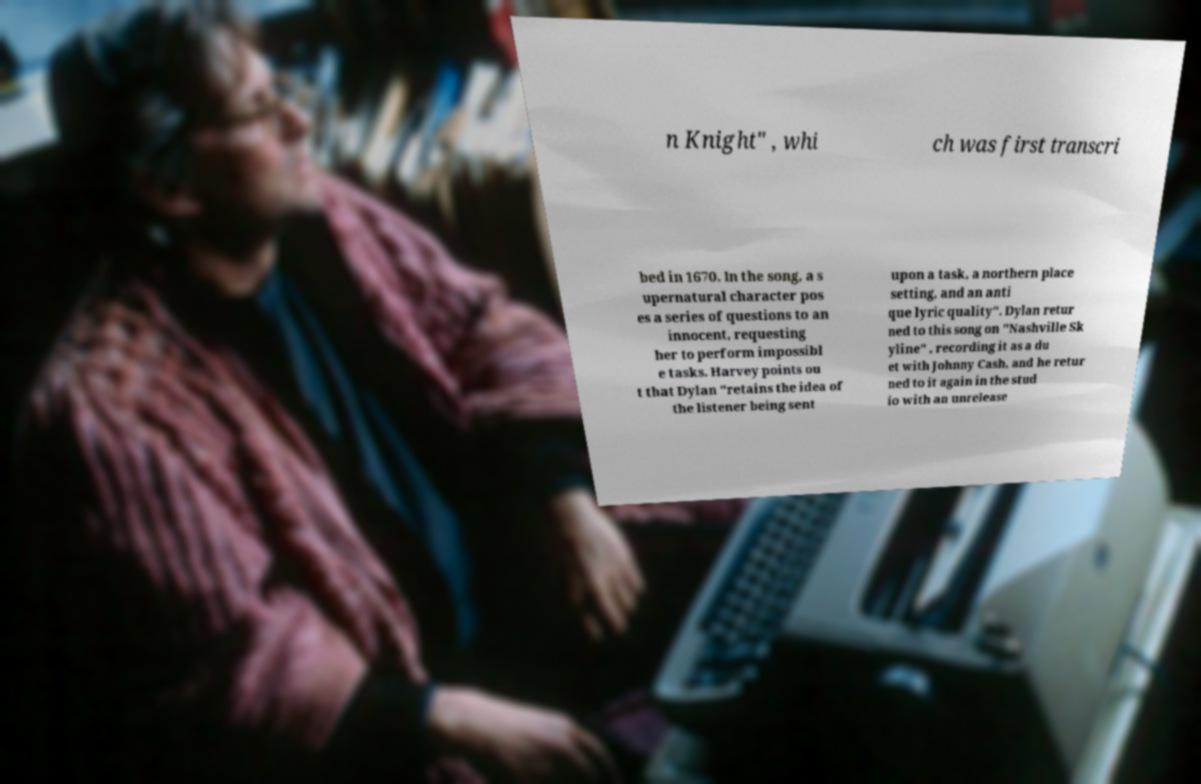I need the written content from this picture converted into text. Can you do that? n Knight" , whi ch was first transcri bed in 1670. In the song, a s upernatural character pos es a series of questions to an innocent, requesting her to perform impossibl e tasks. Harvey points ou t that Dylan "retains the idea of the listener being sent upon a task, a northern place setting, and an anti que lyric quality". Dylan retur ned to this song on "Nashville Sk yline" , recording it as a du et with Johnny Cash, and he retur ned to it again in the stud io with an unrelease 